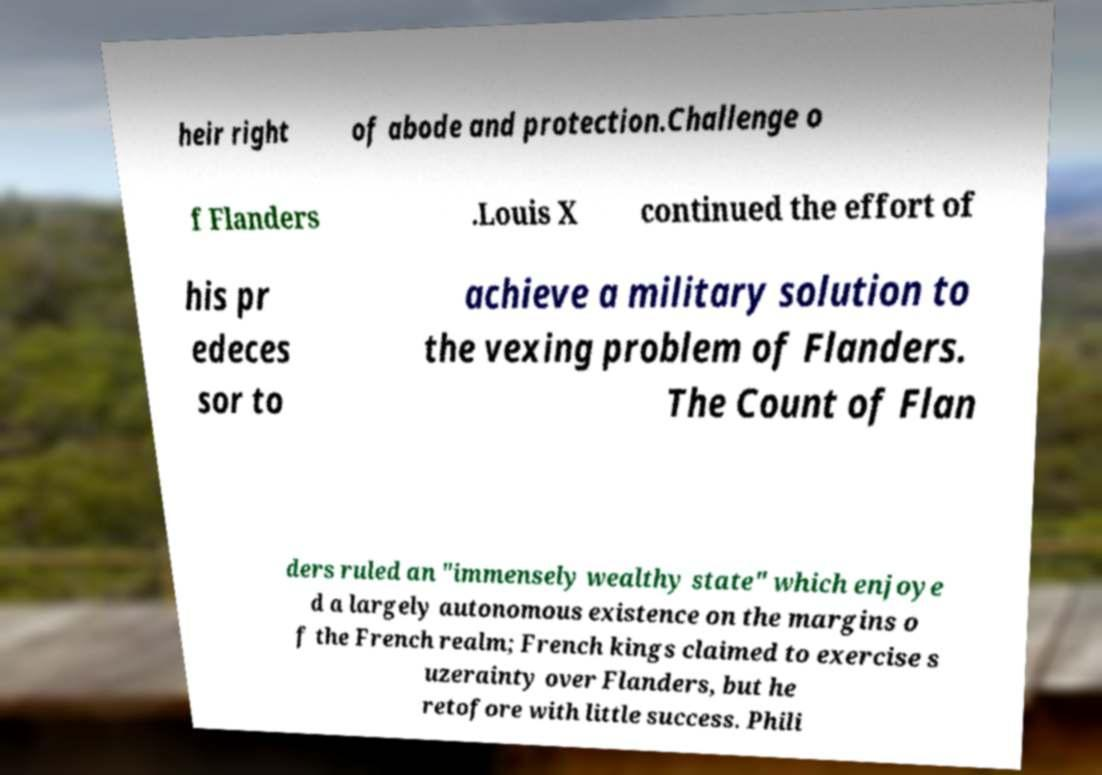What messages or text are displayed in this image? I need them in a readable, typed format. heir right of abode and protection.Challenge o f Flanders .Louis X continued the effort of his pr edeces sor to achieve a military solution to the vexing problem of Flanders. The Count of Flan ders ruled an "immensely wealthy state" which enjoye d a largely autonomous existence on the margins o f the French realm; French kings claimed to exercise s uzerainty over Flanders, but he retofore with little success. Phili 